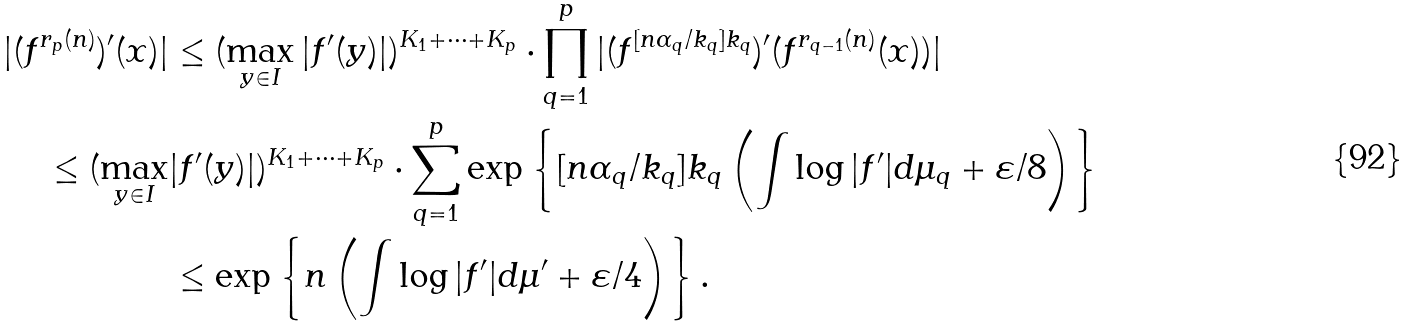<formula> <loc_0><loc_0><loc_500><loc_500>| ( f ^ { r _ { p } ( n ) } ) ^ { \prime } ( x ) | & \leq ( \max _ { y \in I } | f ^ { \prime } ( y ) | ) ^ { K _ { 1 } + \cdots + K _ { p } } \cdot \prod _ { q = 1 } ^ { p } | ( f ^ { [ n \alpha _ { q } / k _ { q } ] k _ { q } } ) ^ { \prime } ( f ^ { r _ { q - 1 } ( n ) } ( x ) ) | \\ \leq ( \max _ { y \in I } & | f ^ { \prime } ( y ) | ) ^ { K _ { 1 } + \cdots + K _ { p } } \cdot \sum _ { q = 1 } ^ { p } \exp \left \{ [ n \alpha _ { q } / k _ { q } ] k _ { q } \left ( \int \log | f ^ { \prime } | d \mu _ { q } + \varepsilon / 8 \right ) \right \} \\ & \leq \exp \left \{ n \left ( \int \log | f ^ { \prime } | d \mu ^ { \prime } + \varepsilon / 4 \right ) \right \} .</formula> 